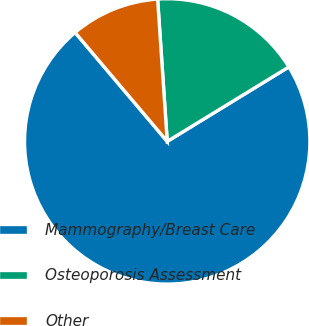Convert chart to OTSL. <chart><loc_0><loc_0><loc_500><loc_500><pie_chart><fcel>Mammography/Breast Care<fcel>Osteoporosis Assessment<fcel>Other<nl><fcel>72.58%<fcel>17.33%<fcel>10.1%<nl></chart> 